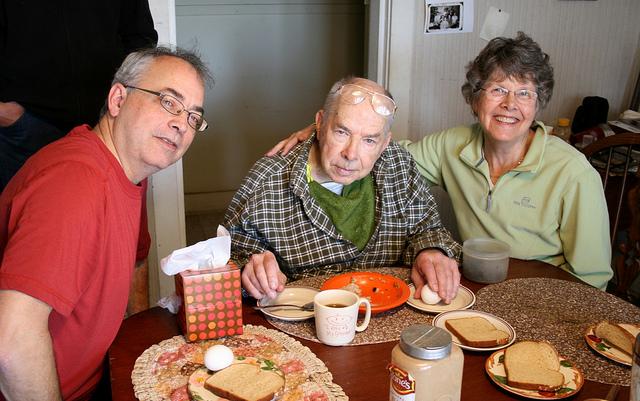What is the man eating?
Answer briefly. Sandwich. What room in the house are the men sitting in?
Answer briefly. Kitchen. How many people are in the picture?
Be succinct. 3. Is a man holding a wine glass?
Write a very short answer. No. What is the man's facial expression?
Keep it brief. Happy. How many people are there in the table?
Short answer required. 3. Are there people here?
Give a very brief answer. Yes. What is this person eating?
Be succinct. Sandwich. What color are the people's shirts?
Write a very short answer. Green red. Are these people eating at a restaurant?
Write a very short answer. No. What is the man drinking?
Concise answer only. Coffee. Does the man have a beard?
Give a very brief answer. No. Is there a water bottle in the picture?
Quick response, please. No. Are both men a healthy weight?
Be succinct. Yes. What type of food is this?
Concise answer only. Bread. How many people are wearing glasses?
Concise answer only. 3. What is on the man's shirt?
Answer briefly. Plaid. How many mugs are there?
Short answer required. 1. Is he hungry?
Keep it brief. Yes. Is the woman's hair brown?
Quick response, please. No. How many women in the room?
Be succinct. 1. What is everyone eating?
Short answer required. Bread. Where is the crown?
Give a very brief answer. Head. Does this man have long hair?
Concise answer only. No. Is the woman wearing a name brand t shirt?
Write a very short answer. Yes. Are both men smiling?
Give a very brief answer. No. Who is the guest of honor at this party?
Keep it brief. Oldest man. What color is the cup?
Short answer required. White. What are the men drinking?
Give a very brief answer. Coffee. What kind of food is on the plate?
Concise answer only. Bread. What is the color of the women's shirt?
Concise answer only. Green. What is the pattern of the woman's sweater?
Give a very brief answer. Solid. Are these teenagers?
Give a very brief answer. No. What are these people eating?
Quick response, please. Sandwiches. Are the people eating meat?
Give a very brief answer. No. Is there kid cups on table?
Be succinct. No. 